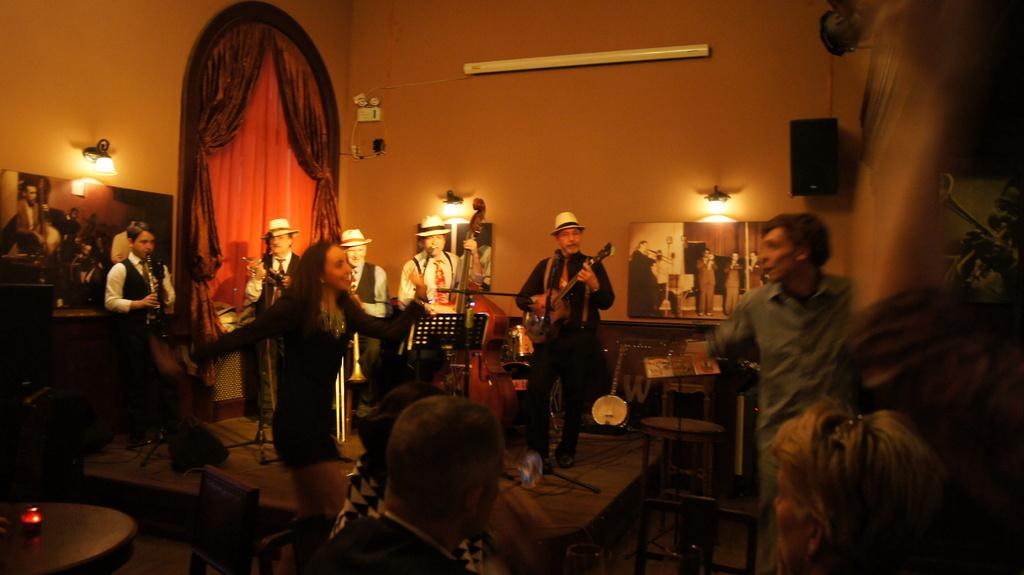How many people are in the image? There is a group of people in the image, but the exact number is not specified. What can be seen in the background of the image? There is a wall, a curtain, and lights in the background of the image. How does the group of people help each other in the image? There is no indication in the image that the group of people is helping each other or engaging in any specific activity. 